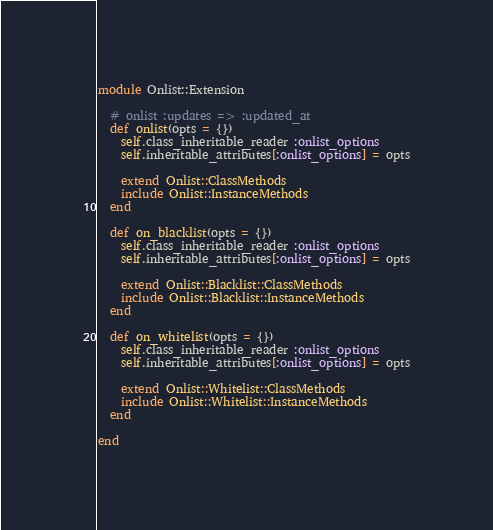Convert code to text. <code><loc_0><loc_0><loc_500><loc_500><_Ruby_>module Onlist::Extension

  # onlist :updates => :updated_at
  def onlist(opts = {})
    self.class_inheritable_reader :onlist_options
    self.inheritable_attributes[:onlist_options] = opts

    extend Onlist::ClassMethods
    include Onlist::InstanceMethods
  end

  def on_blacklist(opts = {})
    self.class_inheritable_reader :onlist_options
    self.inheritable_attributes[:onlist_options] = opts

    extend Onlist::Blacklist::ClassMethods
    include Onlist::Blacklist::InstanceMethods
  end

  def on_whitelist(opts = {})
    self.class_inheritable_reader :onlist_options
    self.inheritable_attributes[:onlist_options] = opts

    extend Onlist::Whitelist::ClassMethods
    include Onlist::Whitelist::InstanceMethods
  end

end
</code> 